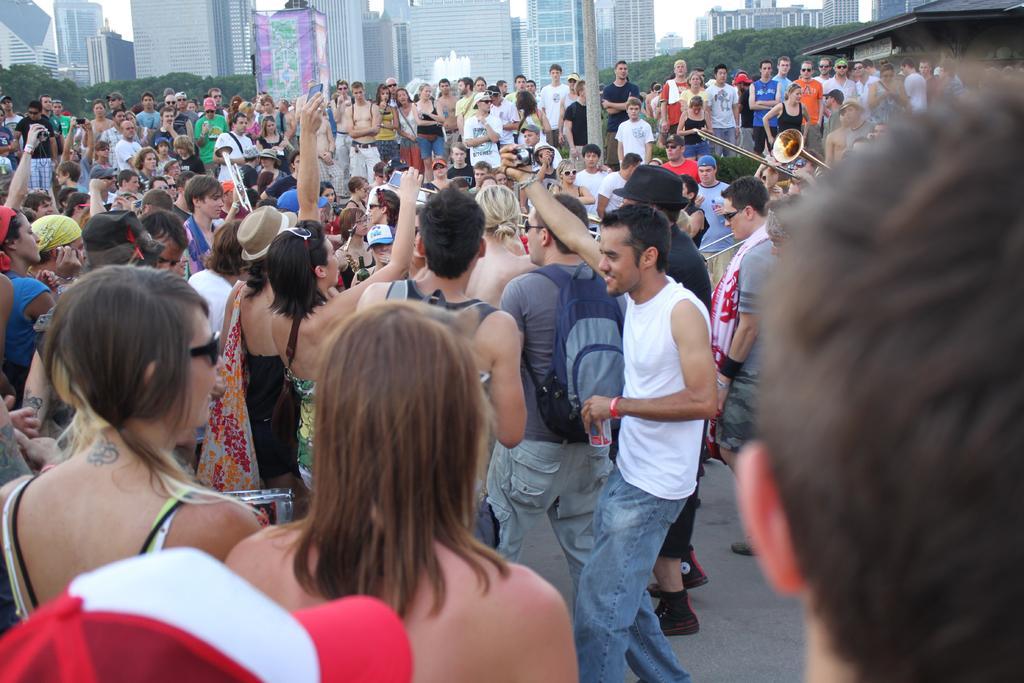How would you summarize this image in a sentence or two? In this image I can see number of people are standing. I can see few of them are wearing hats and few of them are holding musical instruments. I can also see few of them are carrying bags. In the background I can see number of trees and number of buildings. 